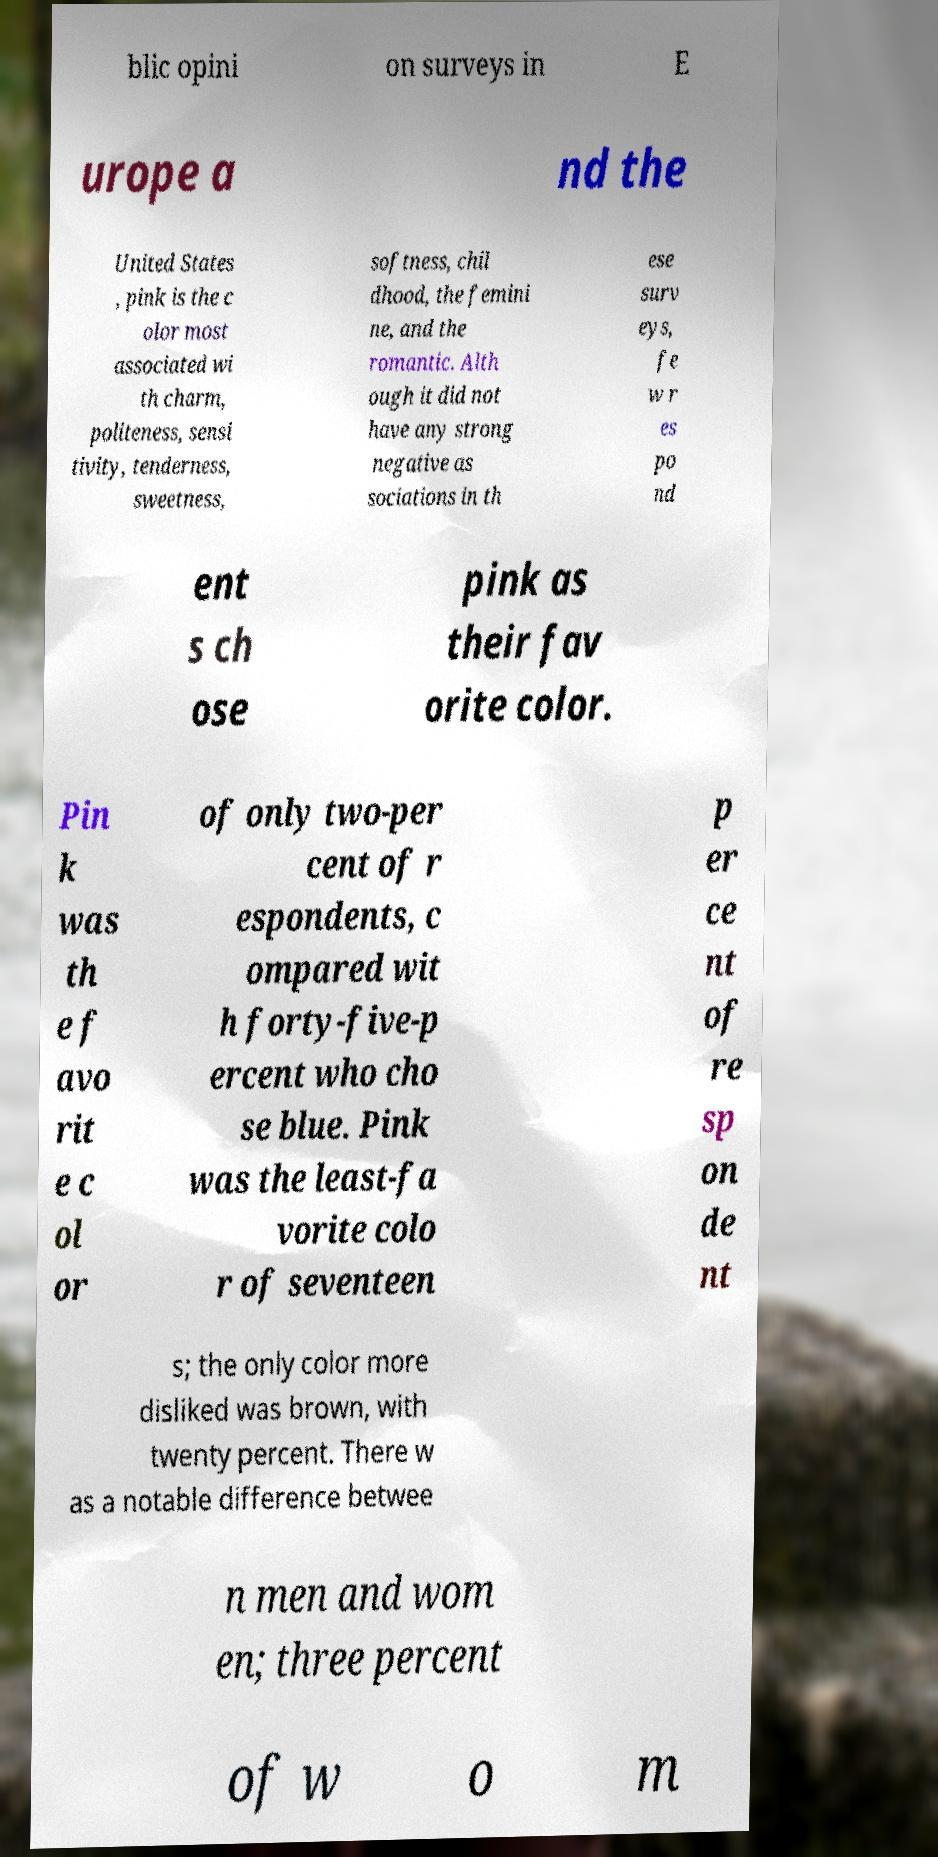Could you assist in decoding the text presented in this image and type it out clearly? blic opini on surveys in E urope a nd the United States , pink is the c olor most associated wi th charm, politeness, sensi tivity, tenderness, sweetness, softness, chil dhood, the femini ne, and the romantic. Alth ough it did not have any strong negative as sociations in th ese surv eys, fe w r es po nd ent s ch ose pink as their fav orite color. Pin k was th e f avo rit e c ol or of only two-per cent of r espondents, c ompared wit h forty-five-p ercent who cho se blue. Pink was the least-fa vorite colo r of seventeen p er ce nt of re sp on de nt s; the only color more disliked was brown, with twenty percent. There w as a notable difference betwee n men and wom en; three percent of w o m 